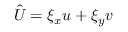<formula> <loc_0><loc_0><loc_500><loc_500>\hat { U } = \xi _ { x } u + \xi _ { y } v</formula> 